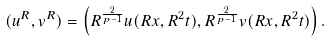Convert formula to latex. <formula><loc_0><loc_0><loc_500><loc_500>( u ^ { R } , v ^ { R } ) = \left ( R ^ { \frac { 2 } { p - 1 } } u ( R x , R ^ { 2 } t ) , R ^ { \frac { 2 } { p - 1 } } v ( R x , R ^ { 2 } t ) \right ) .</formula> 